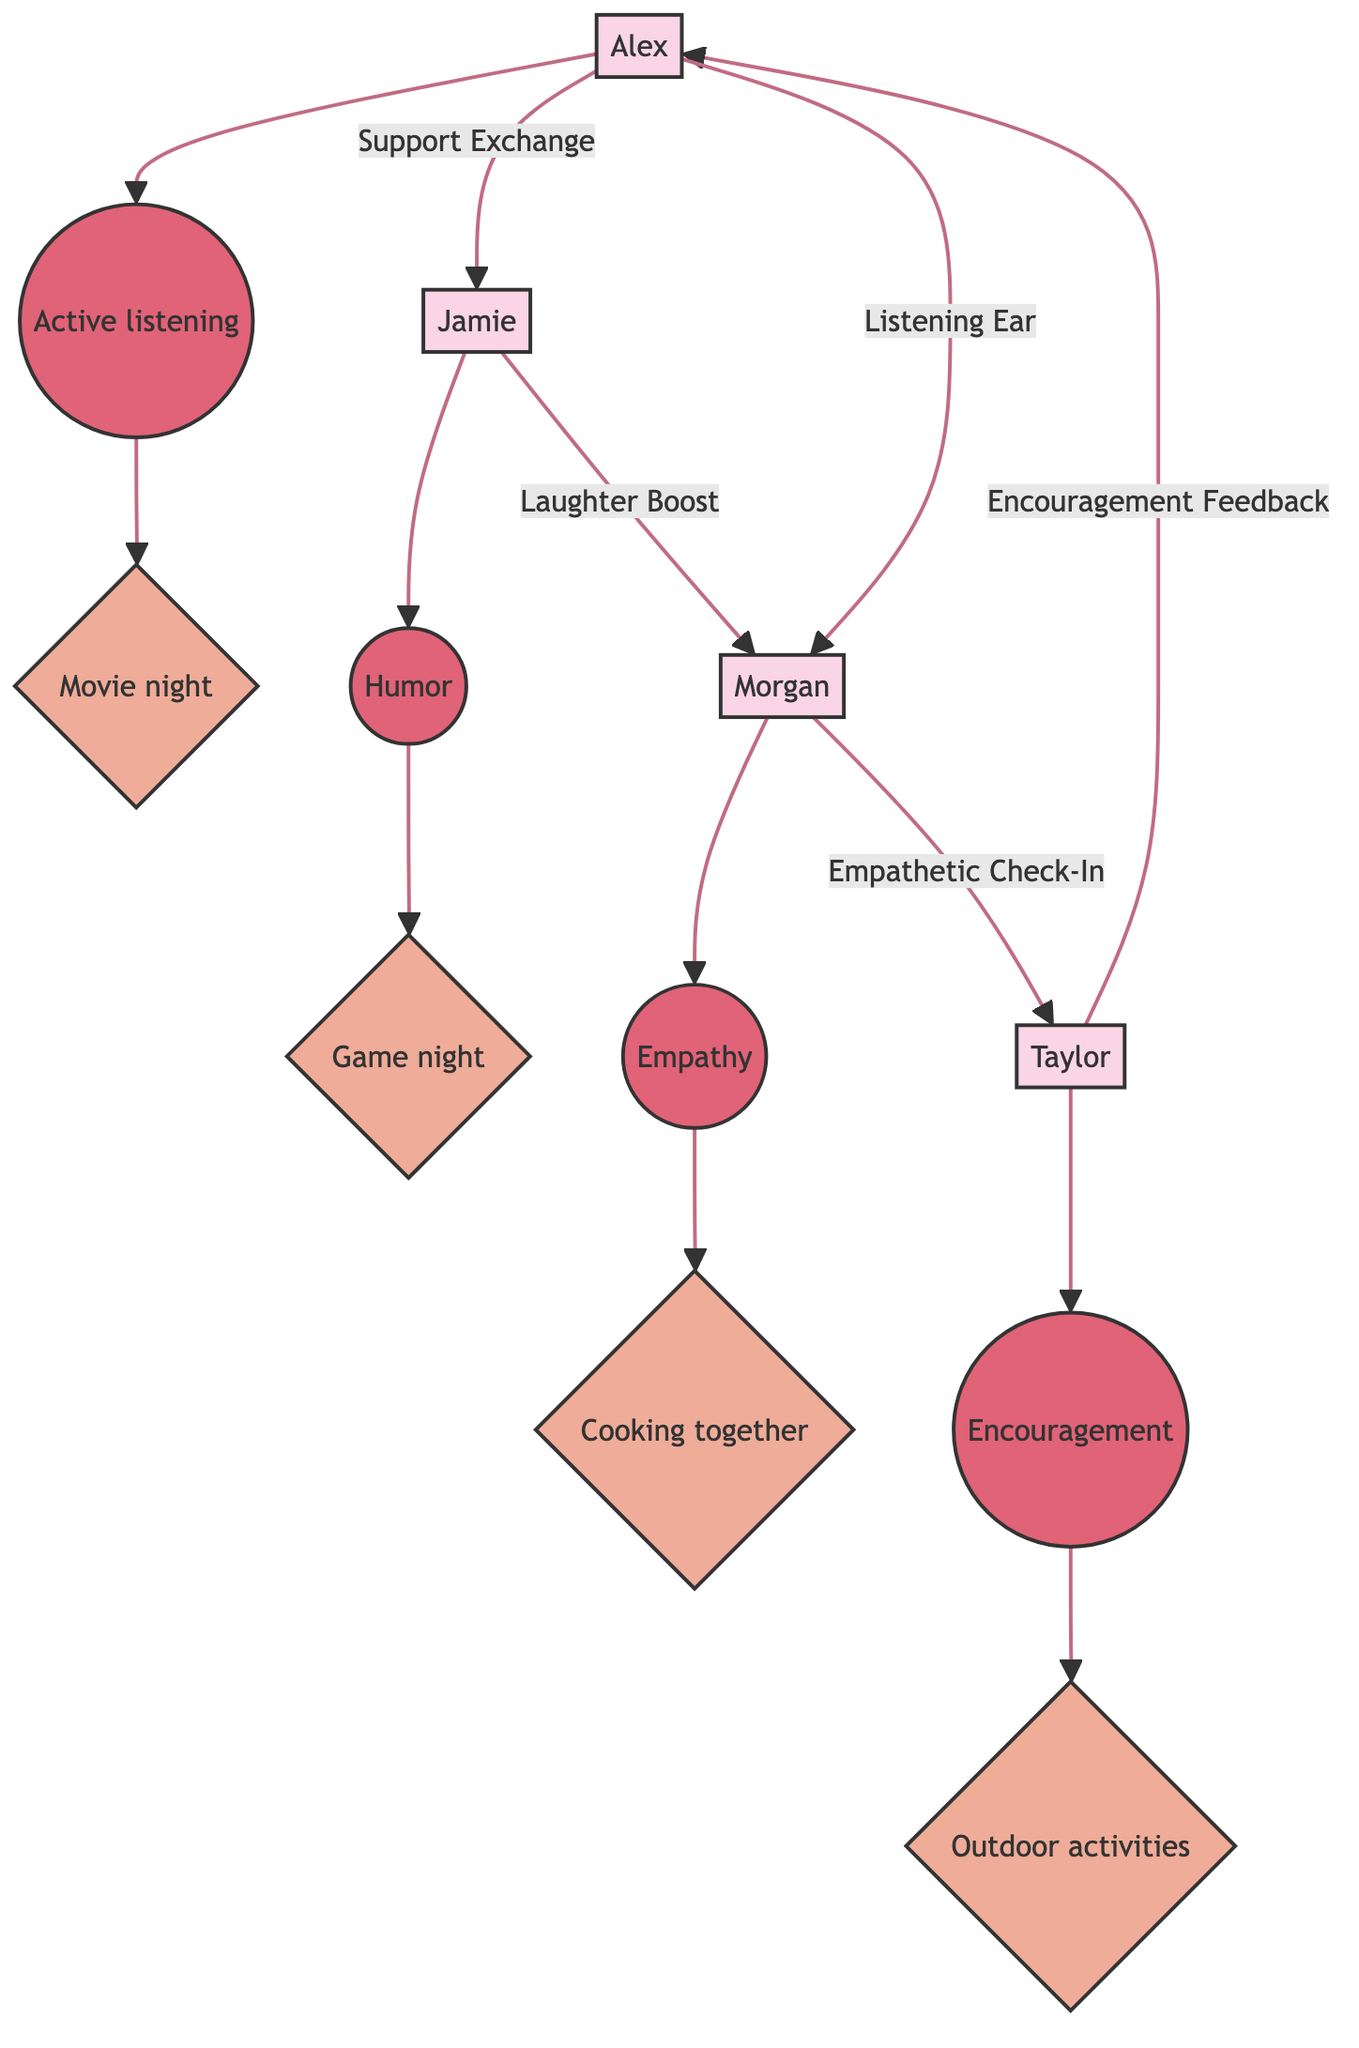What is Jamie's emotional support style? The diagram indicates that Jamie's emotional support style is Humor, as shown next to Jamie's node.
Answer: Humor How many connections are there in total? By counting the arrows (connections) in the diagram, there are five connections depicted.
Answer: 5 Who does Taylor provide encouragement feedback to? Following the arrow from Taylor's node, it points to Alex, indicating that Taylor provides encouragement feedback to Alex.
Answer: Alex What uplifting activity does Morgan suggest? The diagram indicates that Morgan's uplifting activity is Cooking together, which is connected to Morgan's node.
Answer: Cooking together What type of support does Alex offer to Jamie? The diagram shows an arrow labeled "Support Exchange" pointing from Alex to Jamie, indicating that this is the type of support Alex offers to Jamie.
Answer: Support Exchange Which friend is connected to Taylor through an empathetic check-in? The diagram shows that there is an arrow from Morgan to Taylor labeled "Empathetic Check-In," indicating that Morgan is the friend connected to Taylor in this way.
Answer: Morgan Who receives a laughter boost from Jamie? The diagram shows an arrow labeled "Laughter Boost" pointing from Jamie to Morgan, indicating that Morgan receives this boost from Jamie.
Answer: Morgan Which activity is linked to Alex's emotional support style? The diagram connects Alex's emotional support style of Active listening to the uplifting activity of Movie night, showing this relationship directly.
Answer: Movie night Which emotional support style is associated with Taylor? The diagram identifies Taylor's emotional support style as Encouragement, which is shown next to Taylor's node.
Answer: Encouragement 